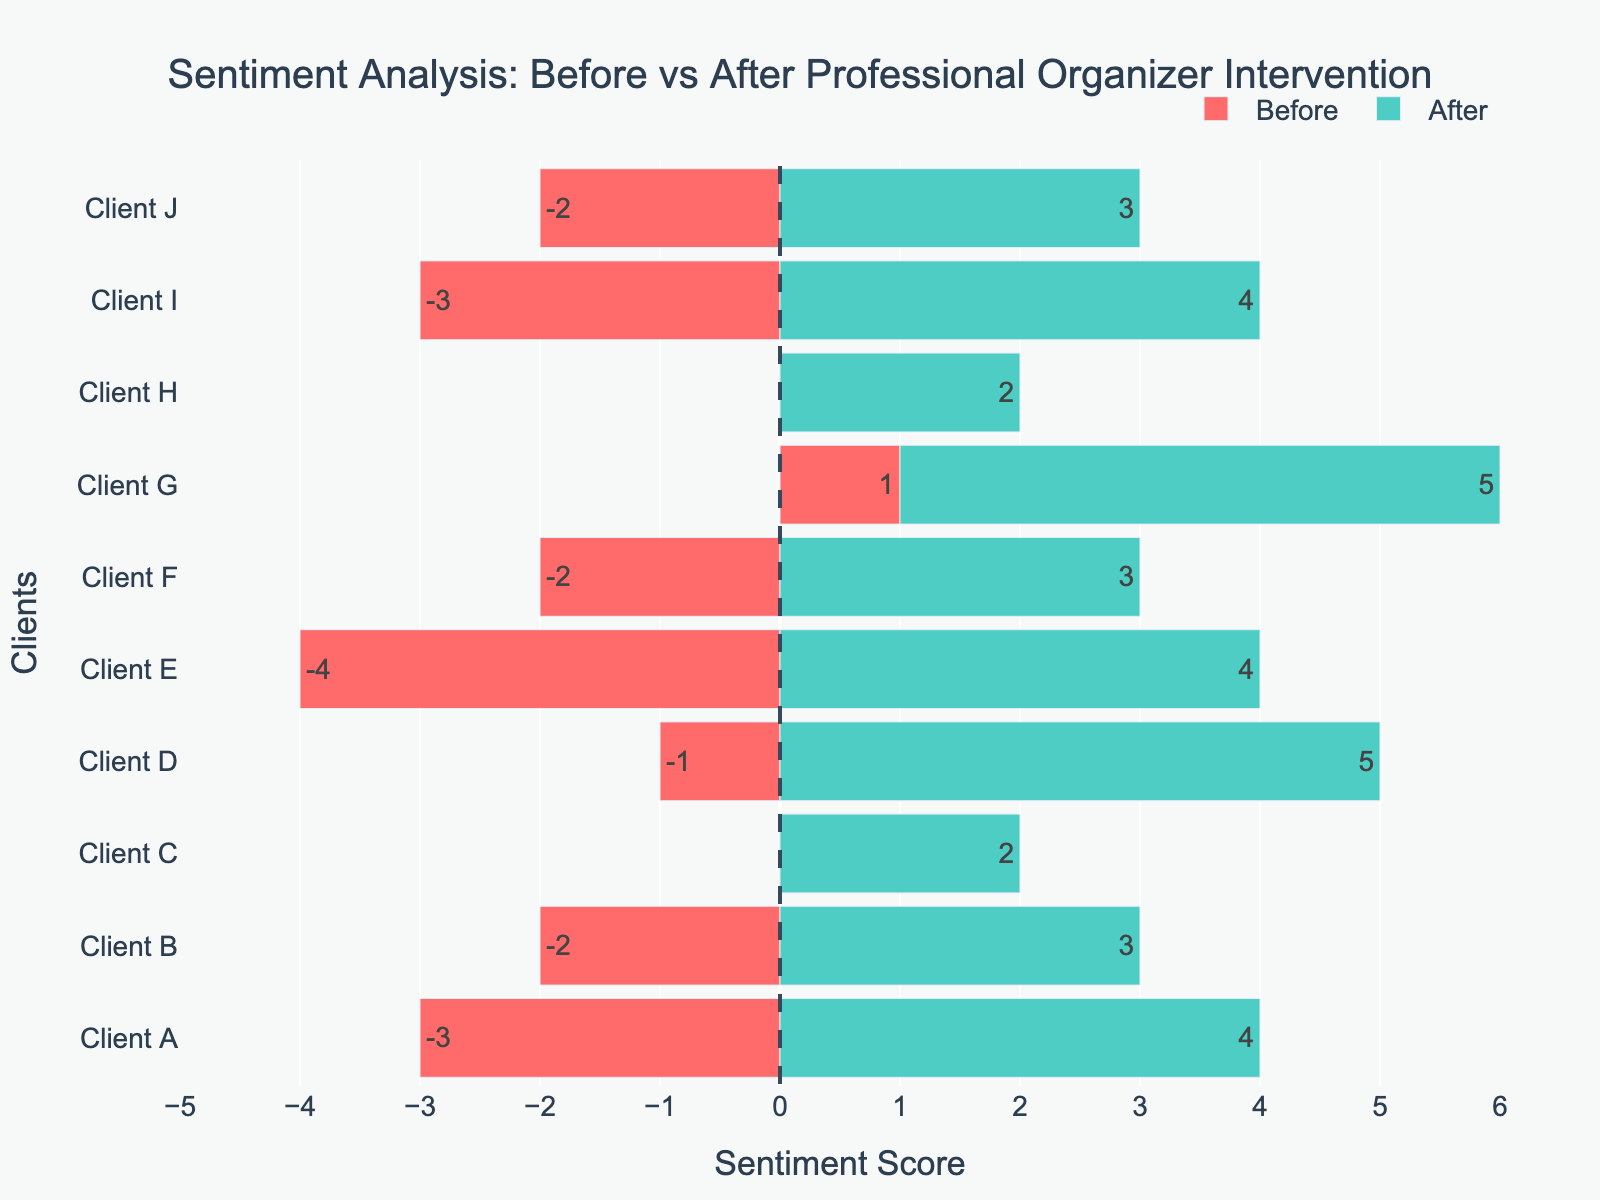Which client showed the greatest increase in sentiment score? To find the client with the greatest increase in sentiment score, subtract the "Before" sentiment score from the "After" sentiment score for each client. The client with the highest resulting value has the greatest increase. Client D shows the greatest increase with a score change from -1 to 5, giving an increase of 6.
Answer: Client D How many clients had a neutral sentiment before the intervention? To determine the number of clients with a neutral sentiment before the intervention, look at the negative sentiment bars (red) and count those with a score of 0. Clients C and H had a neutral sentiment before the intervention.
Answer: 2 Which client had the most positive sentiment after the intervention? To find the client with the most positive sentiment after the intervention, look at the positive sentiment bars (green) and find the highest score. Client G and Client D both have the highest sentiment score of 5.
Answer: Client G and Client D How many clients had a negative sentiment before the intervention? To determine the number of clients with a negative sentiment before the intervention, count the red bars with negative sentiment scores. There are 7 clients with negative sentiments: Clients A, B, D, E, F, I, J.
Answer: 7 What is the average sentiment score before the intervention? Add up all the "Before" sentiment scores and divide by the total number of clients (10). The sum is (-3, -2, 0, -1, -4, -2, 1, 0, -3, -2) = -16. The average is -16/10 = -1.6.
Answer: -1.6 Which client had the smallest change in sentiment score after the intervention? To determine the smallest change, subtract each client's before sentiment score from their after sentiment score and find the smallest difference. Client C and Client H both had a change of 2, which is the smallest.
Answer: Client C and Client H What is the total sentiment change for all clients combined? Calculate each client's sentiment change and sum up the differences. The changes are (7, 5, 2, 6, 8, 5, 4, 2, 7, 5) = 51. The total sentiment change is 51.
Answer: 51 How many clients had a positive sentiment after the intervention? To find the number of clients with a positive sentiment after the intervention, count the green bars with positive scores. All clients (A through J) had a positive sentiment after the intervention.
Answer: 10 Does any client have the same sentiment score before and after the intervention? Compare each client's before and after sentiment score. None of the clients have the same sentiment score before and after the intervention.
Answer: No What is the range of sentiment scores before the intervention? To find the range, identify the highest and lowest sentiment scores before intervention. The highest is 1 (Client G) and the lowest is -4 (Client E). The range is 1 - (-4) = 5.
Answer: 5 